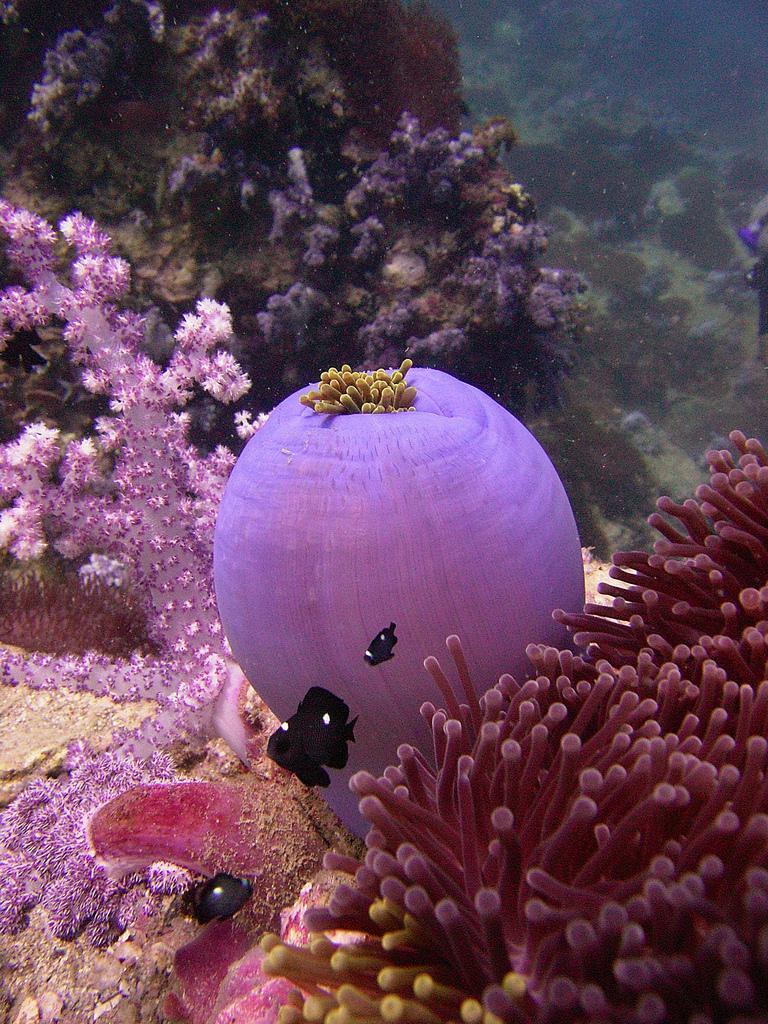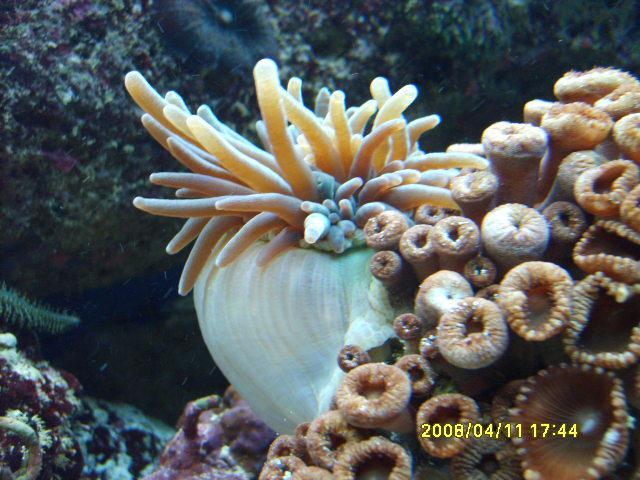The first image is the image on the left, the second image is the image on the right. Considering the images on both sides, is "An image shows brownish anemone tendrils emerging from a rounded, inflated looking purplish sac." valid? Answer yes or no. Yes. The first image is the image on the left, the second image is the image on the right. For the images displayed, is the sentence "Some elements of the coral are pink in at least one of the images." factually correct? Answer yes or no. Yes. 